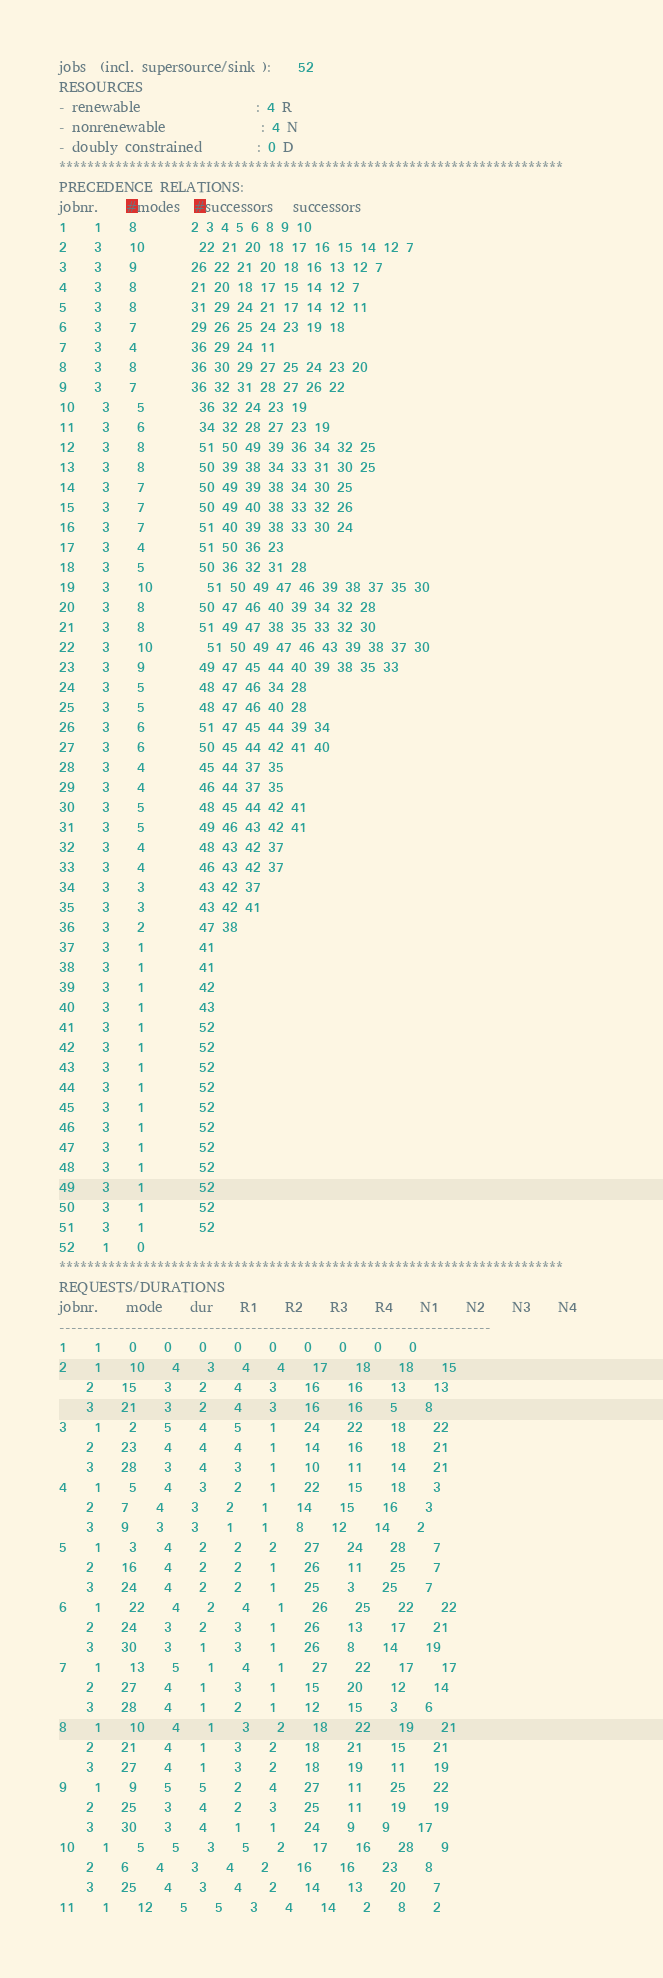<code> <loc_0><loc_0><loc_500><loc_500><_ObjectiveC_>jobs  (incl. supersource/sink ):	52
RESOURCES
- renewable                 : 4 R
- nonrenewable              : 4 N
- doubly constrained        : 0 D
************************************************************************
PRECEDENCE RELATIONS:
jobnr.    #modes  #successors   successors
1	1	8		2 3 4 5 6 8 9 10 
2	3	10		22 21 20 18 17 16 15 14 12 7 
3	3	9		26 22 21 20 18 16 13 12 7 
4	3	8		21 20 18 17 15 14 12 7 
5	3	8		31 29 24 21 17 14 12 11 
6	3	7		29 26 25 24 23 19 18 
7	3	4		36 29 24 11 
8	3	8		36 30 29 27 25 24 23 20 
9	3	7		36 32 31 28 27 26 22 
10	3	5		36 32 24 23 19 
11	3	6		34 32 28 27 23 19 
12	3	8		51 50 49 39 36 34 32 25 
13	3	8		50 39 38 34 33 31 30 25 
14	3	7		50 49 39 38 34 30 25 
15	3	7		50 49 40 38 33 32 26 
16	3	7		51 40 39 38 33 30 24 
17	3	4		51 50 36 23 
18	3	5		50 36 32 31 28 
19	3	10		51 50 49 47 46 39 38 37 35 30 
20	3	8		50 47 46 40 39 34 32 28 
21	3	8		51 49 47 38 35 33 32 30 
22	3	10		51 50 49 47 46 43 39 38 37 30 
23	3	9		49 47 45 44 40 39 38 35 33 
24	3	5		48 47 46 34 28 
25	3	5		48 47 46 40 28 
26	3	6		51 47 45 44 39 34 
27	3	6		50 45 44 42 41 40 
28	3	4		45 44 37 35 
29	3	4		46 44 37 35 
30	3	5		48 45 44 42 41 
31	3	5		49 46 43 42 41 
32	3	4		48 43 42 37 
33	3	4		46 43 42 37 
34	3	3		43 42 37 
35	3	3		43 42 41 
36	3	2		47 38 
37	3	1		41 
38	3	1		41 
39	3	1		42 
40	3	1		43 
41	3	1		52 
42	3	1		52 
43	3	1		52 
44	3	1		52 
45	3	1		52 
46	3	1		52 
47	3	1		52 
48	3	1		52 
49	3	1		52 
50	3	1		52 
51	3	1		52 
52	1	0		
************************************************************************
REQUESTS/DURATIONS
jobnr.	mode	dur	R1	R2	R3	R4	N1	N2	N3	N4	
------------------------------------------------------------------------
1	1	0	0	0	0	0	0	0	0	0	
2	1	10	4	3	4	4	17	18	18	15	
	2	15	3	2	4	3	16	16	13	13	
	3	21	3	2	4	3	16	16	5	8	
3	1	2	5	4	5	1	24	22	18	22	
	2	23	4	4	4	1	14	16	18	21	
	3	28	3	4	3	1	10	11	14	21	
4	1	5	4	3	2	1	22	15	18	3	
	2	7	4	3	2	1	14	15	16	3	
	3	9	3	3	1	1	8	12	14	2	
5	1	3	4	2	2	2	27	24	28	7	
	2	16	4	2	2	1	26	11	25	7	
	3	24	4	2	2	1	25	3	25	7	
6	1	22	4	2	4	1	26	25	22	22	
	2	24	3	2	3	1	26	13	17	21	
	3	30	3	1	3	1	26	8	14	19	
7	1	13	5	1	4	1	27	22	17	17	
	2	27	4	1	3	1	15	20	12	14	
	3	28	4	1	2	1	12	15	3	6	
8	1	10	4	1	3	2	18	22	19	21	
	2	21	4	1	3	2	18	21	15	21	
	3	27	4	1	3	2	18	19	11	19	
9	1	9	5	5	2	4	27	11	25	22	
	2	25	3	4	2	3	25	11	19	19	
	3	30	3	4	1	1	24	9	9	17	
10	1	5	5	3	5	2	17	16	28	9	
	2	6	4	3	4	2	16	16	23	8	
	3	25	4	3	4	2	14	13	20	7	
11	1	12	5	5	3	4	14	2	8	2	</code> 